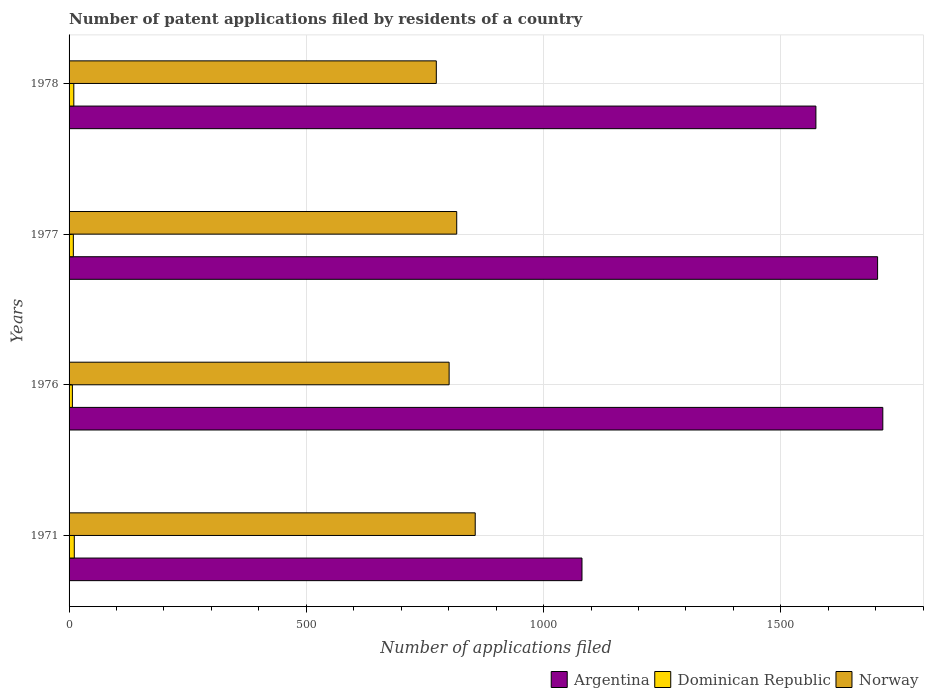How many different coloured bars are there?
Offer a very short reply. 3. How many groups of bars are there?
Offer a very short reply. 4. Are the number of bars per tick equal to the number of legend labels?
Your answer should be very brief. Yes. How many bars are there on the 4th tick from the top?
Offer a terse response. 3. What is the label of the 3rd group of bars from the top?
Your answer should be very brief. 1976. What is the number of applications filed in Dominican Republic in 1971?
Your answer should be compact. 11. Across all years, what is the minimum number of applications filed in Norway?
Offer a terse response. 774. In which year was the number of applications filed in Norway minimum?
Offer a very short reply. 1978. What is the difference between the number of applications filed in Dominican Republic in 1971 and that in 1976?
Your response must be concise. 4. What is the difference between the number of applications filed in Argentina in 1971 and the number of applications filed in Norway in 1978?
Offer a terse response. 307. What is the average number of applications filed in Norway per year?
Your answer should be very brief. 812. In the year 1976, what is the difference between the number of applications filed in Dominican Republic and number of applications filed in Argentina?
Offer a very short reply. -1708. In how many years, is the number of applications filed in Norway greater than 400 ?
Offer a very short reply. 4. What is the ratio of the number of applications filed in Norway in 1971 to that in 1977?
Provide a succinct answer. 1.05. Is the number of applications filed in Argentina in 1977 less than that in 1978?
Offer a terse response. No. Is the difference between the number of applications filed in Dominican Republic in 1971 and 1978 greater than the difference between the number of applications filed in Argentina in 1971 and 1978?
Provide a short and direct response. Yes. What is the difference between the highest and the lowest number of applications filed in Argentina?
Give a very brief answer. 634. Is the sum of the number of applications filed in Norway in 1971 and 1977 greater than the maximum number of applications filed in Argentina across all years?
Provide a short and direct response. No. What does the 2nd bar from the top in 1978 represents?
Your answer should be compact. Dominican Republic. What does the 2nd bar from the bottom in 1976 represents?
Your answer should be very brief. Dominican Republic. How many bars are there?
Ensure brevity in your answer.  12. Are all the bars in the graph horizontal?
Ensure brevity in your answer.  Yes. What is the difference between two consecutive major ticks on the X-axis?
Keep it short and to the point. 500. Does the graph contain any zero values?
Keep it short and to the point. No. Where does the legend appear in the graph?
Provide a succinct answer. Bottom right. How many legend labels are there?
Offer a very short reply. 3. How are the legend labels stacked?
Your answer should be compact. Horizontal. What is the title of the graph?
Keep it short and to the point. Number of patent applications filed by residents of a country. What is the label or title of the X-axis?
Your answer should be very brief. Number of applications filed. What is the label or title of the Y-axis?
Provide a succinct answer. Years. What is the Number of applications filed in Argentina in 1971?
Make the answer very short. 1081. What is the Number of applications filed in Dominican Republic in 1971?
Your answer should be very brief. 11. What is the Number of applications filed of Norway in 1971?
Ensure brevity in your answer.  856. What is the Number of applications filed in Argentina in 1976?
Keep it short and to the point. 1715. What is the Number of applications filed of Norway in 1976?
Give a very brief answer. 801. What is the Number of applications filed in Argentina in 1977?
Give a very brief answer. 1704. What is the Number of applications filed in Dominican Republic in 1977?
Your response must be concise. 9. What is the Number of applications filed in Norway in 1977?
Offer a very short reply. 817. What is the Number of applications filed in Argentina in 1978?
Offer a terse response. 1574. What is the Number of applications filed of Dominican Republic in 1978?
Your answer should be compact. 10. What is the Number of applications filed in Norway in 1978?
Provide a short and direct response. 774. Across all years, what is the maximum Number of applications filed in Argentina?
Ensure brevity in your answer.  1715. Across all years, what is the maximum Number of applications filed in Norway?
Offer a terse response. 856. Across all years, what is the minimum Number of applications filed of Argentina?
Keep it short and to the point. 1081. Across all years, what is the minimum Number of applications filed in Dominican Republic?
Give a very brief answer. 7. Across all years, what is the minimum Number of applications filed in Norway?
Give a very brief answer. 774. What is the total Number of applications filed in Argentina in the graph?
Offer a terse response. 6074. What is the total Number of applications filed of Norway in the graph?
Your answer should be very brief. 3248. What is the difference between the Number of applications filed of Argentina in 1971 and that in 1976?
Keep it short and to the point. -634. What is the difference between the Number of applications filed of Argentina in 1971 and that in 1977?
Your answer should be compact. -623. What is the difference between the Number of applications filed in Dominican Republic in 1971 and that in 1977?
Provide a succinct answer. 2. What is the difference between the Number of applications filed of Norway in 1971 and that in 1977?
Your answer should be compact. 39. What is the difference between the Number of applications filed in Argentina in 1971 and that in 1978?
Keep it short and to the point. -493. What is the difference between the Number of applications filed in Dominican Republic in 1971 and that in 1978?
Keep it short and to the point. 1. What is the difference between the Number of applications filed of Norway in 1971 and that in 1978?
Offer a terse response. 82. What is the difference between the Number of applications filed of Norway in 1976 and that in 1977?
Keep it short and to the point. -16. What is the difference between the Number of applications filed of Argentina in 1976 and that in 1978?
Ensure brevity in your answer.  141. What is the difference between the Number of applications filed in Dominican Republic in 1976 and that in 1978?
Your response must be concise. -3. What is the difference between the Number of applications filed in Argentina in 1977 and that in 1978?
Ensure brevity in your answer.  130. What is the difference between the Number of applications filed in Dominican Republic in 1977 and that in 1978?
Your answer should be very brief. -1. What is the difference between the Number of applications filed of Argentina in 1971 and the Number of applications filed of Dominican Republic in 1976?
Give a very brief answer. 1074. What is the difference between the Number of applications filed in Argentina in 1971 and the Number of applications filed in Norway in 1976?
Your response must be concise. 280. What is the difference between the Number of applications filed in Dominican Republic in 1971 and the Number of applications filed in Norway in 1976?
Offer a very short reply. -790. What is the difference between the Number of applications filed of Argentina in 1971 and the Number of applications filed of Dominican Republic in 1977?
Provide a succinct answer. 1072. What is the difference between the Number of applications filed of Argentina in 1971 and the Number of applications filed of Norway in 1977?
Provide a succinct answer. 264. What is the difference between the Number of applications filed in Dominican Republic in 1971 and the Number of applications filed in Norway in 1977?
Give a very brief answer. -806. What is the difference between the Number of applications filed in Argentina in 1971 and the Number of applications filed in Dominican Republic in 1978?
Give a very brief answer. 1071. What is the difference between the Number of applications filed of Argentina in 1971 and the Number of applications filed of Norway in 1978?
Your response must be concise. 307. What is the difference between the Number of applications filed of Dominican Republic in 1971 and the Number of applications filed of Norway in 1978?
Provide a short and direct response. -763. What is the difference between the Number of applications filed in Argentina in 1976 and the Number of applications filed in Dominican Republic in 1977?
Give a very brief answer. 1706. What is the difference between the Number of applications filed in Argentina in 1976 and the Number of applications filed in Norway in 1977?
Keep it short and to the point. 898. What is the difference between the Number of applications filed of Dominican Republic in 1976 and the Number of applications filed of Norway in 1977?
Offer a very short reply. -810. What is the difference between the Number of applications filed of Argentina in 1976 and the Number of applications filed of Dominican Republic in 1978?
Provide a succinct answer. 1705. What is the difference between the Number of applications filed of Argentina in 1976 and the Number of applications filed of Norway in 1978?
Provide a succinct answer. 941. What is the difference between the Number of applications filed in Dominican Republic in 1976 and the Number of applications filed in Norway in 1978?
Provide a short and direct response. -767. What is the difference between the Number of applications filed in Argentina in 1977 and the Number of applications filed in Dominican Republic in 1978?
Make the answer very short. 1694. What is the difference between the Number of applications filed of Argentina in 1977 and the Number of applications filed of Norway in 1978?
Keep it short and to the point. 930. What is the difference between the Number of applications filed in Dominican Republic in 1977 and the Number of applications filed in Norway in 1978?
Keep it short and to the point. -765. What is the average Number of applications filed in Argentina per year?
Give a very brief answer. 1518.5. What is the average Number of applications filed in Dominican Republic per year?
Offer a terse response. 9.25. What is the average Number of applications filed in Norway per year?
Make the answer very short. 812. In the year 1971, what is the difference between the Number of applications filed in Argentina and Number of applications filed in Dominican Republic?
Ensure brevity in your answer.  1070. In the year 1971, what is the difference between the Number of applications filed in Argentina and Number of applications filed in Norway?
Offer a terse response. 225. In the year 1971, what is the difference between the Number of applications filed of Dominican Republic and Number of applications filed of Norway?
Provide a succinct answer. -845. In the year 1976, what is the difference between the Number of applications filed in Argentina and Number of applications filed in Dominican Republic?
Your answer should be compact. 1708. In the year 1976, what is the difference between the Number of applications filed in Argentina and Number of applications filed in Norway?
Offer a terse response. 914. In the year 1976, what is the difference between the Number of applications filed in Dominican Republic and Number of applications filed in Norway?
Keep it short and to the point. -794. In the year 1977, what is the difference between the Number of applications filed of Argentina and Number of applications filed of Dominican Republic?
Offer a terse response. 1695. In the year 1977, what is the difference between the Number of applications filed in Argentina and Number of applications filed in Norway?
Offer a terse response. 887. In the year 1977, what is the difference between the Number of applications filed in Dominican Republic and Number of applications filed in Norway?
Offer a terse response. -808. In the year 1978, what is the difference between the Number of applications filed of Argentina and Number of applications filed of Dominican Republic?
Your answer should be compact. 1564. In the year 1978, what is the difference between the Number of applications filed in Argentina and Number of applications filed in Norway?
Your response must be concise. 800. In the year 1978, what is the difference between the Number of applications filed in Dominican Republic and Number of applications filed in Norway?
Your answer should be compact. -764. What is the ratio of the Number of applications filed of Argentina in 1971 to that in 1976?
Keep it short and to the point. 0.63. What is the ratio of the Number of applications filed in Dominican Republic in 1971 to that in 1976?
Your answer should be compact. 1.57. What is the ratio of the Number of applications filed of Norway in 1971 to that in 1976?
Offer a very short reply. 1.07. What is the ratio of the Number of applications filed in Argentina in 1971 to that in 1977?
Offer a very short reply. 0.63. What is the ratio of the Number of applications filed of Dominican Republic in 1971 to that in 1977?
Your answer should be very brief. 1.22. What is the ratio of the Number of applications filed in Norway in 1971 to that in 1977?
Offer a terse response. 1.05. What is the ratio of the Number of applications filed in Argentina in 1971 to that in 1978?
Provide a succinct answer. 0.69. What is the ratio of the Number of applications filed in Dominican Republic in 1971 to that in 1978?
Provide a succinct answer. 1.1. What is the ratio of the Number of applications filed in Norway in 1971 to that in 1978?
Ensure brevity in your answer.  1.11. What is the ratio of the Number of applications filed in Norway in 1976 to that in 1977?
Provide a short and direct response. 0.98. What is the ratio of the Number of applications filed in Argentina in 1976 to that in 1978?
Give a very brief answer. 1.09. What is the ratio of the Number of applications filed in Dominican Republic in 1976 to that in 1978?
Offer a terse response. 0.7. What is the ratio of the Number of applications filed in Norway in 1976 to that in 1978?
Provide a succinct answer. 1.03. What is the ratio of the Number of applications filed of Argentina in 1977 to that in 1978?
Provide a succinct answer. 1.08. What is the ratio of the Number of applications filed in Dominican Republic in 1977 to that in 1978?
Your answer should be compact. 0.9. What is the ratio of the Number of applications filed of Norway in 1977 to that in 1978?
Provide a succinct answer. 1.06. What is the difference between the highest and the second highest Number of applications filed of Dominican Republic?
Your answer should be very brief. 1. What is the difference between the highest and the second highest Number of applications filed of Norway?
Offer a very short reply. 39. What is the difference between the highest and the lowest Number of applications filed of Argentina?
Offer a terse response. 634. What is the difference between the highest and the lowest Number of applications filed in Norway?
Offer a very short reply. 82. 